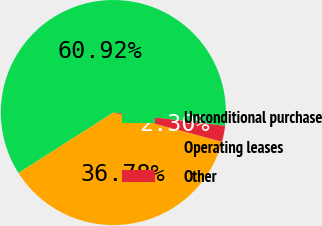Convert chart. <chart><loc_0><loc_0><loc_500><loc_500><pie_chart><fcel>Unconditional purchase<fcel>Operating leases<fcel>Other<nl><fcel>60.92%<fcel>36.78%<fcel>2.3%<nl></chart> 